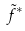<formula> <loc_0><loc_0><loc_500><loc_500>\tilde { f } ^ { * }</formula> 